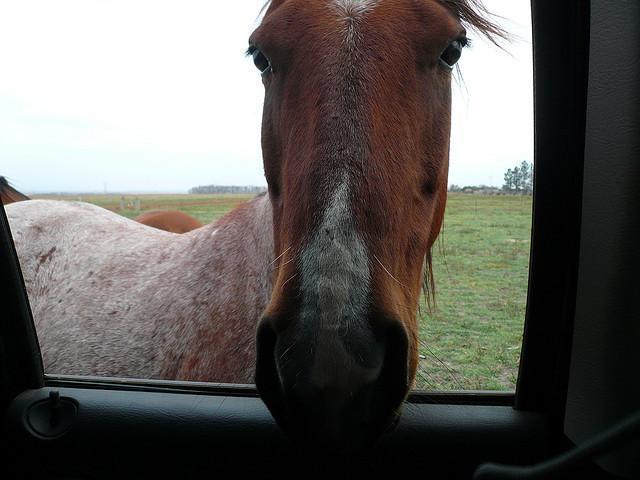How many animals are there?
Give a very brief answer. 1. How many people are in this photo?
Give a very brief answer. 0. 